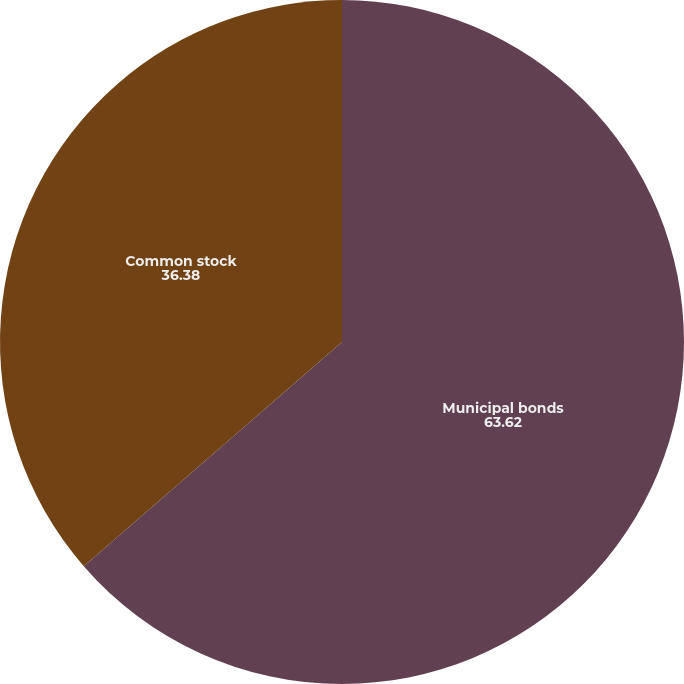Convert chart. <chart><loc_0><loc_0><loc_500><loc_500><pie_chart><fcel>Municipal bonds<fcel>Common stock<nl><fcel>63.62%<fcel>36.38%<nl></chart> 